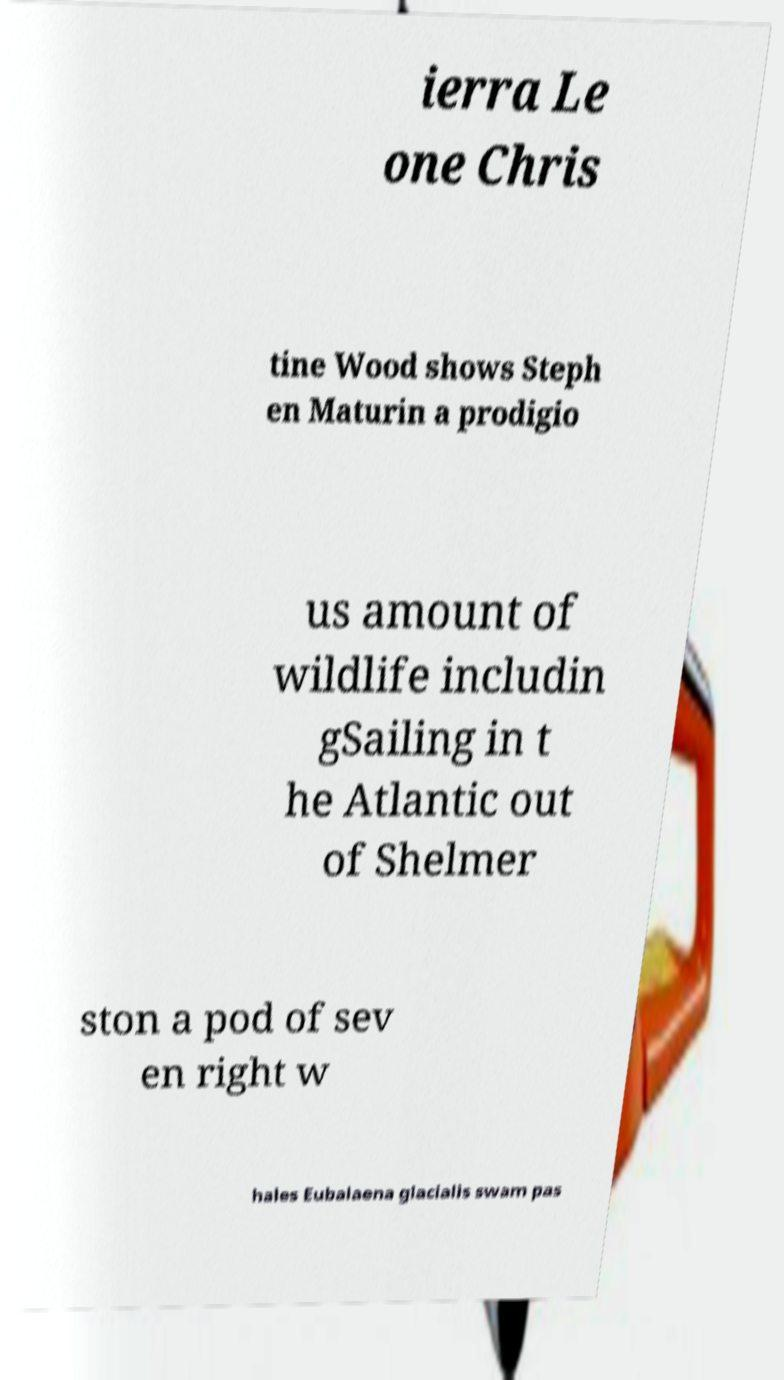Please read and relay the text visible in this image. What does it say? ierra Le one Chris tine Wood shows Steph en Maturin a prodigio us amount of wildlife includin gSailing in t he Atlantic out of Shelmer ston a pod of sev en right w hales Eubalaena glacialis swam pas 